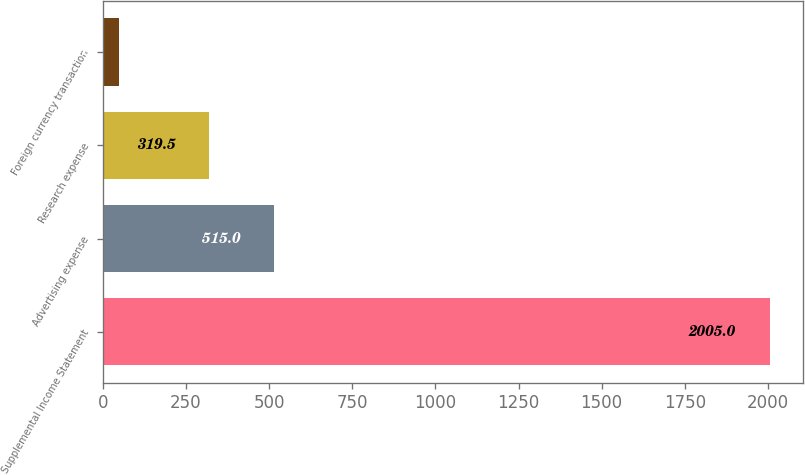Convert chart to OTSL. <chart><loc_0><loc_0><loc_500><loc_500><bar_chart><fcel>Supplemental Income Statement<fcel>Advertising expense<fcel>Research expense<fcel>Foreign currency transaction<nl><fcel>2005<fcel>515<fcel>319.5<fcel>50<nl></chart> 